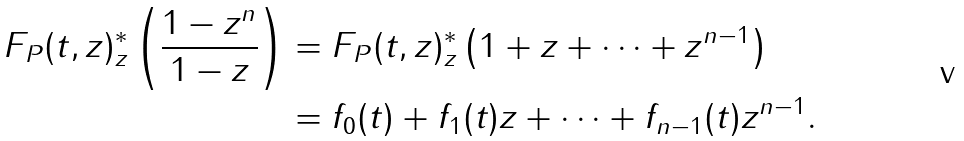Convert formula to latex. <formula><loc_0><loc_0><loc_500><loc_500>F _ { P } ( t , z ) ^ { * } _ { z } \left ( \frac { 1 - z ^ { n } } { 1 - z } \right ) & = F _ { P } ( t , z ) ^ { * } _ { z } \left ( 1 + z + \cdots + z ^ { n - 1 } \right ) \\ & = f _ { 0 } ( t ) + f _ { 1 } ( t ) z + \cdots + f _ { n - 1 } ( t ) z ^ { n - 1 } .</formula> 